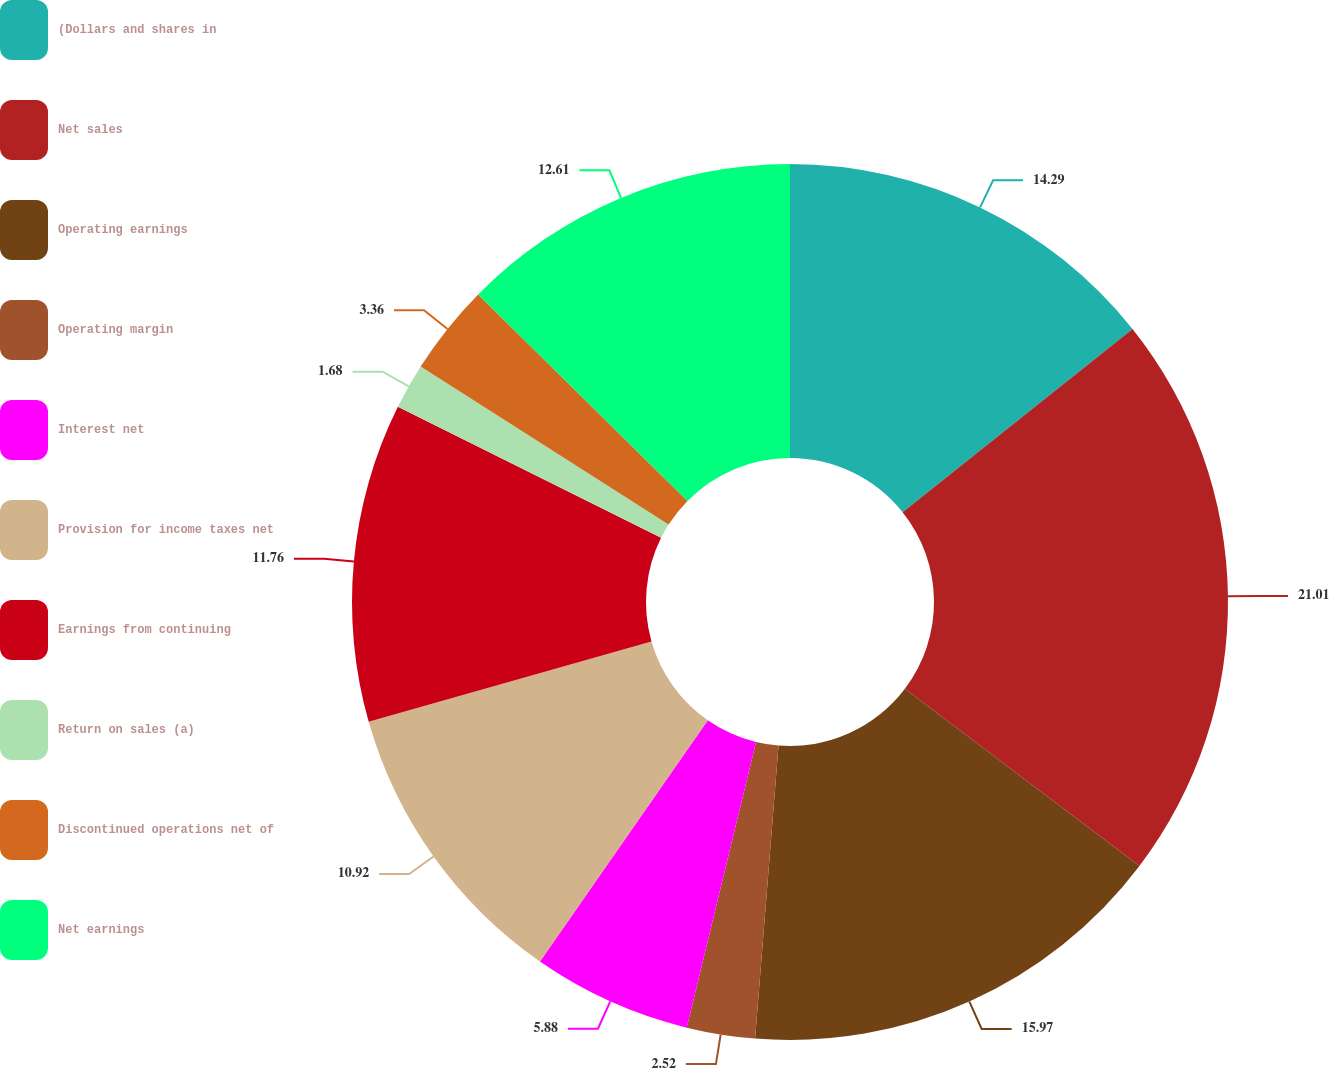Convert chart. <chart><loc_0><loc_0><loc_500><loc_500><pie_chart><fcel>(Dollars and shares in<fcel>Net sales<fcel>Operating earnings<fcel>Operating margin<fcel>Interest net<fcel>Provision for income taxes net<fcel>Earnings from continuing<fcel>Return on sales (a)<fcel>Discontinued operations net of<fcel>Net earnings<nl><fcel>14.29%<fcel>21.01%<fcel>15.97%<fcel>2.52%<fcel>5.88%<fcel>10.92%<fcel>11.76%<fcel>1.68%<fcel>3.36%<fcel>12.61%<nl></chart> 